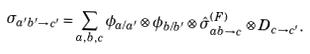<formula> <loc_0><loc_0><loc_500><loc_500>\sigma _ { a ^ { \prime } b ^ { \prime } \rightarrow c ^ { \prime } } = \sum _ { a , b , c } \phi _ { a / a ^ { \prime } } \otimes \phi _ { b / b ^ { \prime } } \otimes \hat { \sigma } _ { a b \rightarrow c } ^ { ( F ) } \otimes D _ { c \rightarrow c ^ { \prime } } .</formula> 